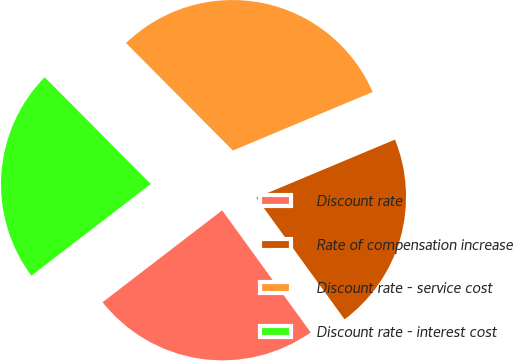<chart> <loc_0><loc_0><loc_500><loc_500><pie_chart><fcel>Discount rate<fcel>Rate of compensation increase<fcel>Discount rate - service cost<fcel>Discount rate - interest cost<nl><fcel>24.56%<fcel>21.33%<fcel>31.14%<fcel>22.97%<nl></chart> 